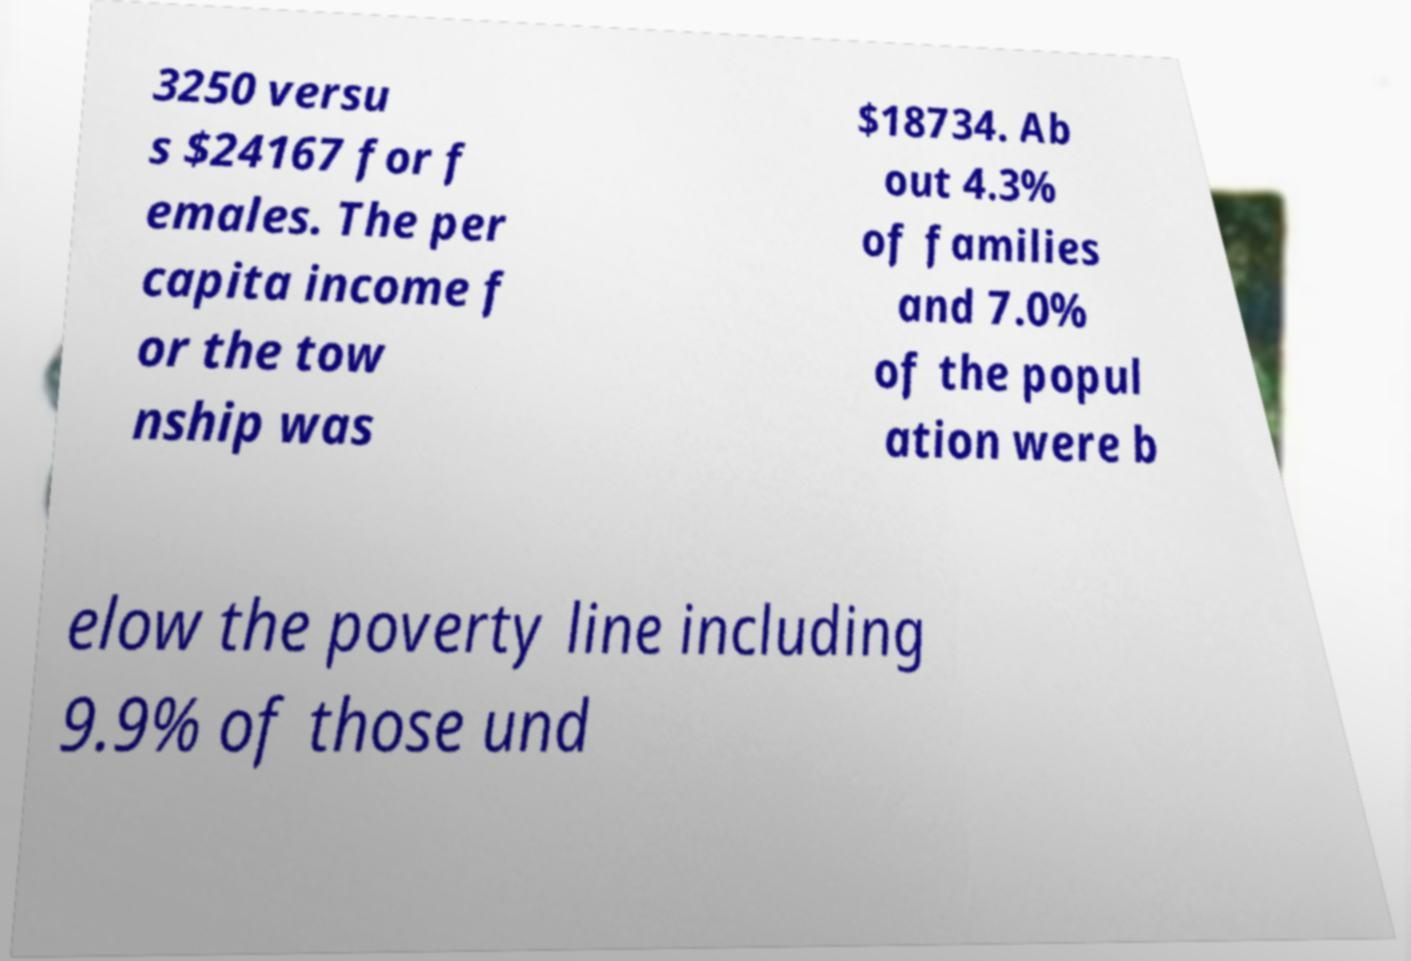I need the written content from this picture converted into text. Can you do that? 3250 versu s $24167 for f emales. The per capita income f or the tow nship was $18734. Ab out 4.3% of families and 7.0% of the popul ation were b elow the poverty line including 9.9% of those und 